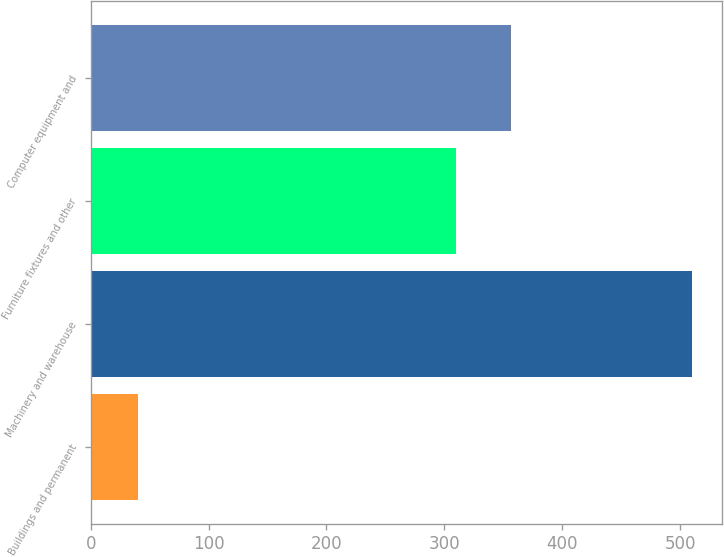Convert chart. <chart><loc_0><loc_0><loc_500><loc_500><bar_chart><fcel>Buildings and permanent<fcel>Machinery and warehouse<fcel>Furniture fixtures and other<fcel>Computer equipment and<nl><fcel>40<fcel>510<fcel>310<fcel>357<nl></chart> 